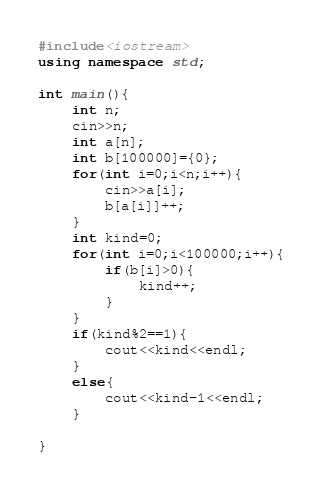Convert code to text. <code><loc_0><loc_0><loc_500><loc_500><_C++_>#include<iostream>
using namespace std;

int main(){
	int n;
	cin>>n;
	int a[n];
	int b[100000]={0};
	for(int i=0;i<n;i++){
		cin>>a[i];
		b[a[i]]++;
	}
	int kind=0;
	for(int i=0;i<100000;i++){
		if(b[i]>0){
			kind++;
		}
	}
	if(kind%2==1){
		cout<<kind<<endl;
	}
	else{
		cout<<kind-1<<endl;
	}
			
}		</code> 